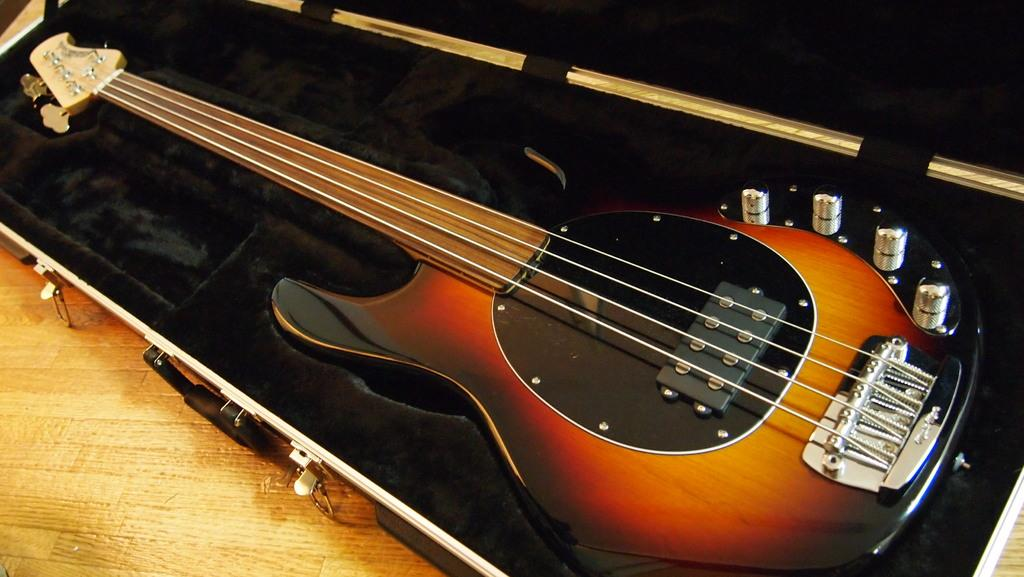What musical instrument is present in the image? There is a guitar in the image. How is the guitar being stored or transported in the image? The guitar is placed in a box. What type of lipstick can be seen on the guitar in the image? There is no lipstick or any cosmetic product visible on the guitar in the image. 